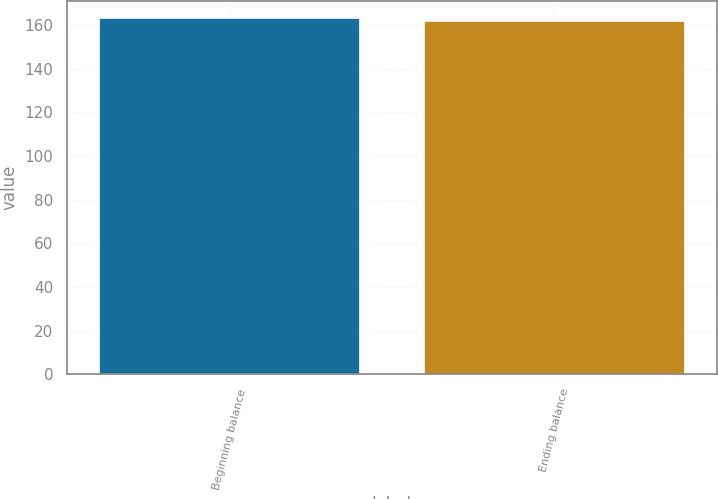Convert chart. <chart><loc_0><loc_0><loc_500><loc_500><bar_chart><fcel>Beginning balance<fcel>Ending balance<nl><fcel>163<fcel>162<nl></chart> 